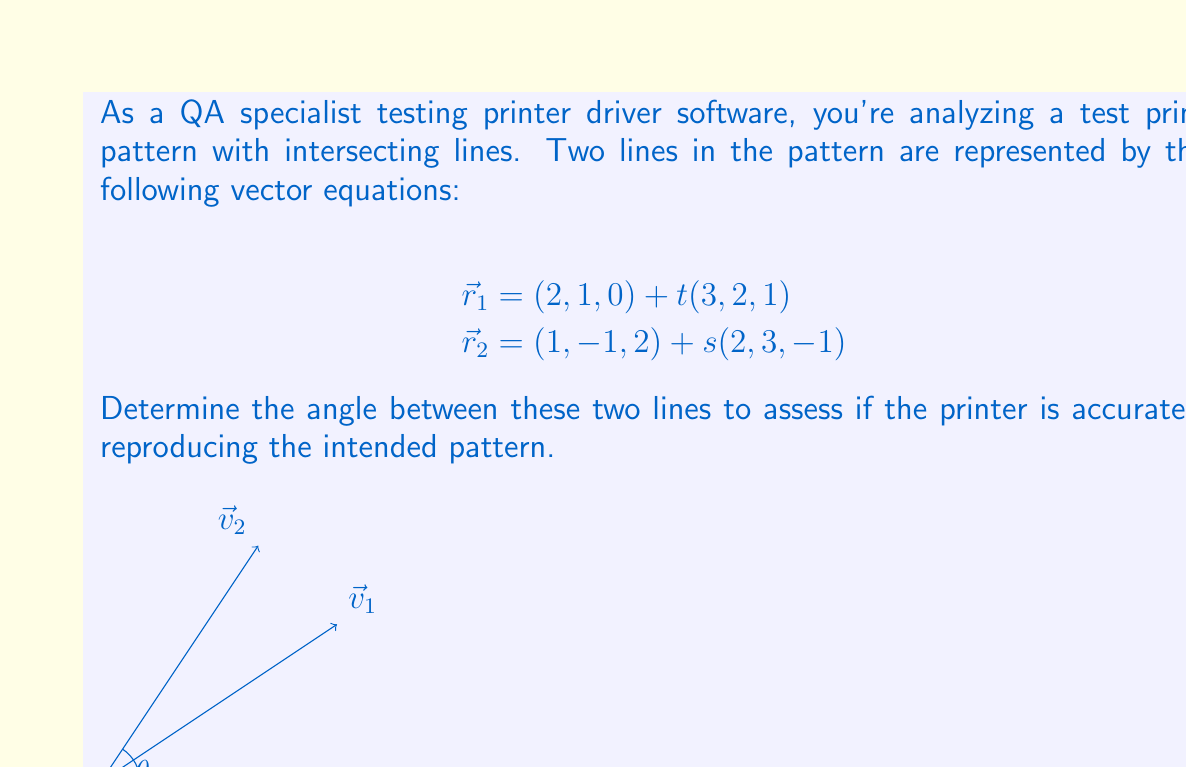Can you answer this question? To find the angle between two lines, we can use the direction vectors of the lines and the dot product formula. Let's proceed step-by-step:

1) The direction vectors of the lines are:
   $$\vec{v}_1 = (3, 2, 1)$$
   $$\vec{v}_2 = (2, 3, -1)$$

2) The angle $\theta$ between two vectors is given by:
   $$\cos \theta = \frac{\vec{v}_1 \cdot \vec{v}_2}{|\vec{v}_1||\vec{v}_2|}$$

3) Calculate the dot product $\vec{v}_1 \cdot \vec{v}_2$:
   $$(3)(2) + (2)(3) + (1)(-1) = 6 + 6 - 1 = 11$$

4) Calculate the magnitudes:
   $$|\vec{v}_1| = \sqrt{3^2 + 2^2 + 1^2} = \sqrt{14}$$
   $$|\vec{v}_2| = \sqrt{2^2 + 3^2 + (-1)^2} = \sqrt{14}$$

5) Substitute into the formula:
   $$\cos \theta = \frac{11}{\sqrt{14}\sqrt{14}} = \frac{11}{14}$$

6) Take the inverse cosine (arccos) of both sides:
   $$\theta = \arccos(\frac{11}{14})$$

7) Calculate the result:
   $$\theta \approx 0.5149 \text{ radians} \approx 29.50°$$
Answer: $29.50°$ 